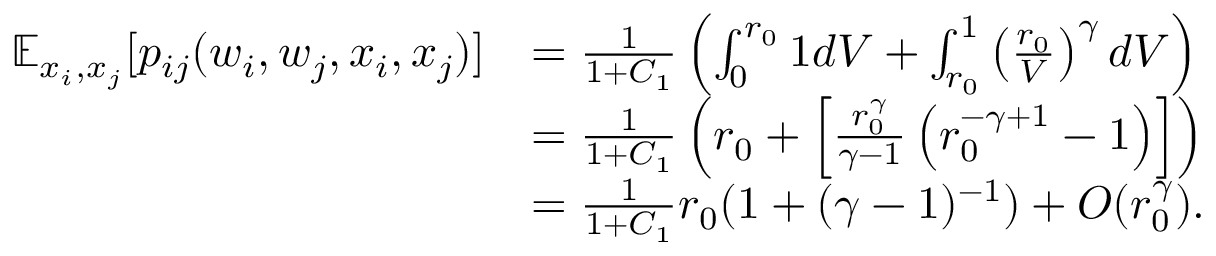<formula> <loc_0><loc_0><loc_500><loc_500>\begin{array} { r l } { \mathbb { E } _ { x _ { i } , x _ { j } } [ p _ { i j } ( w _ { i } , w _ { j } , x _ { i } , x _ { j } ) ] } & { = \frac { 1 } { 1 + C _ { 1 } } \left ( \int _ { 0 } ^ { r _ { 0 } } 1 d V + \int _ { r _ { 0 } } ^ { 1 } \left ( \frac { r _ { 0 } } { V } \right ) ^ { \gamma } d V \right ) } \\ & { = \frac { 1 } { 1 + C _ { 1 } } \left ( r _ { 0 } + \left [ \frac { r _ { 0 } ^ { \gamma } } { \gamma - 1 } \left ( r _ { 0 } ^ { - \gamma + 1 } - 1 \right ) \right ] \right ) } \\ & { = \frac { 1 } { 1 + C _ { 1 } } r _ { 0 } ( 1 + ( \gamma - 1 ) ^ { - 1 } ) + O ( r _ { 0 } ^ { \gamma } ) . } \end{array}</formula> 